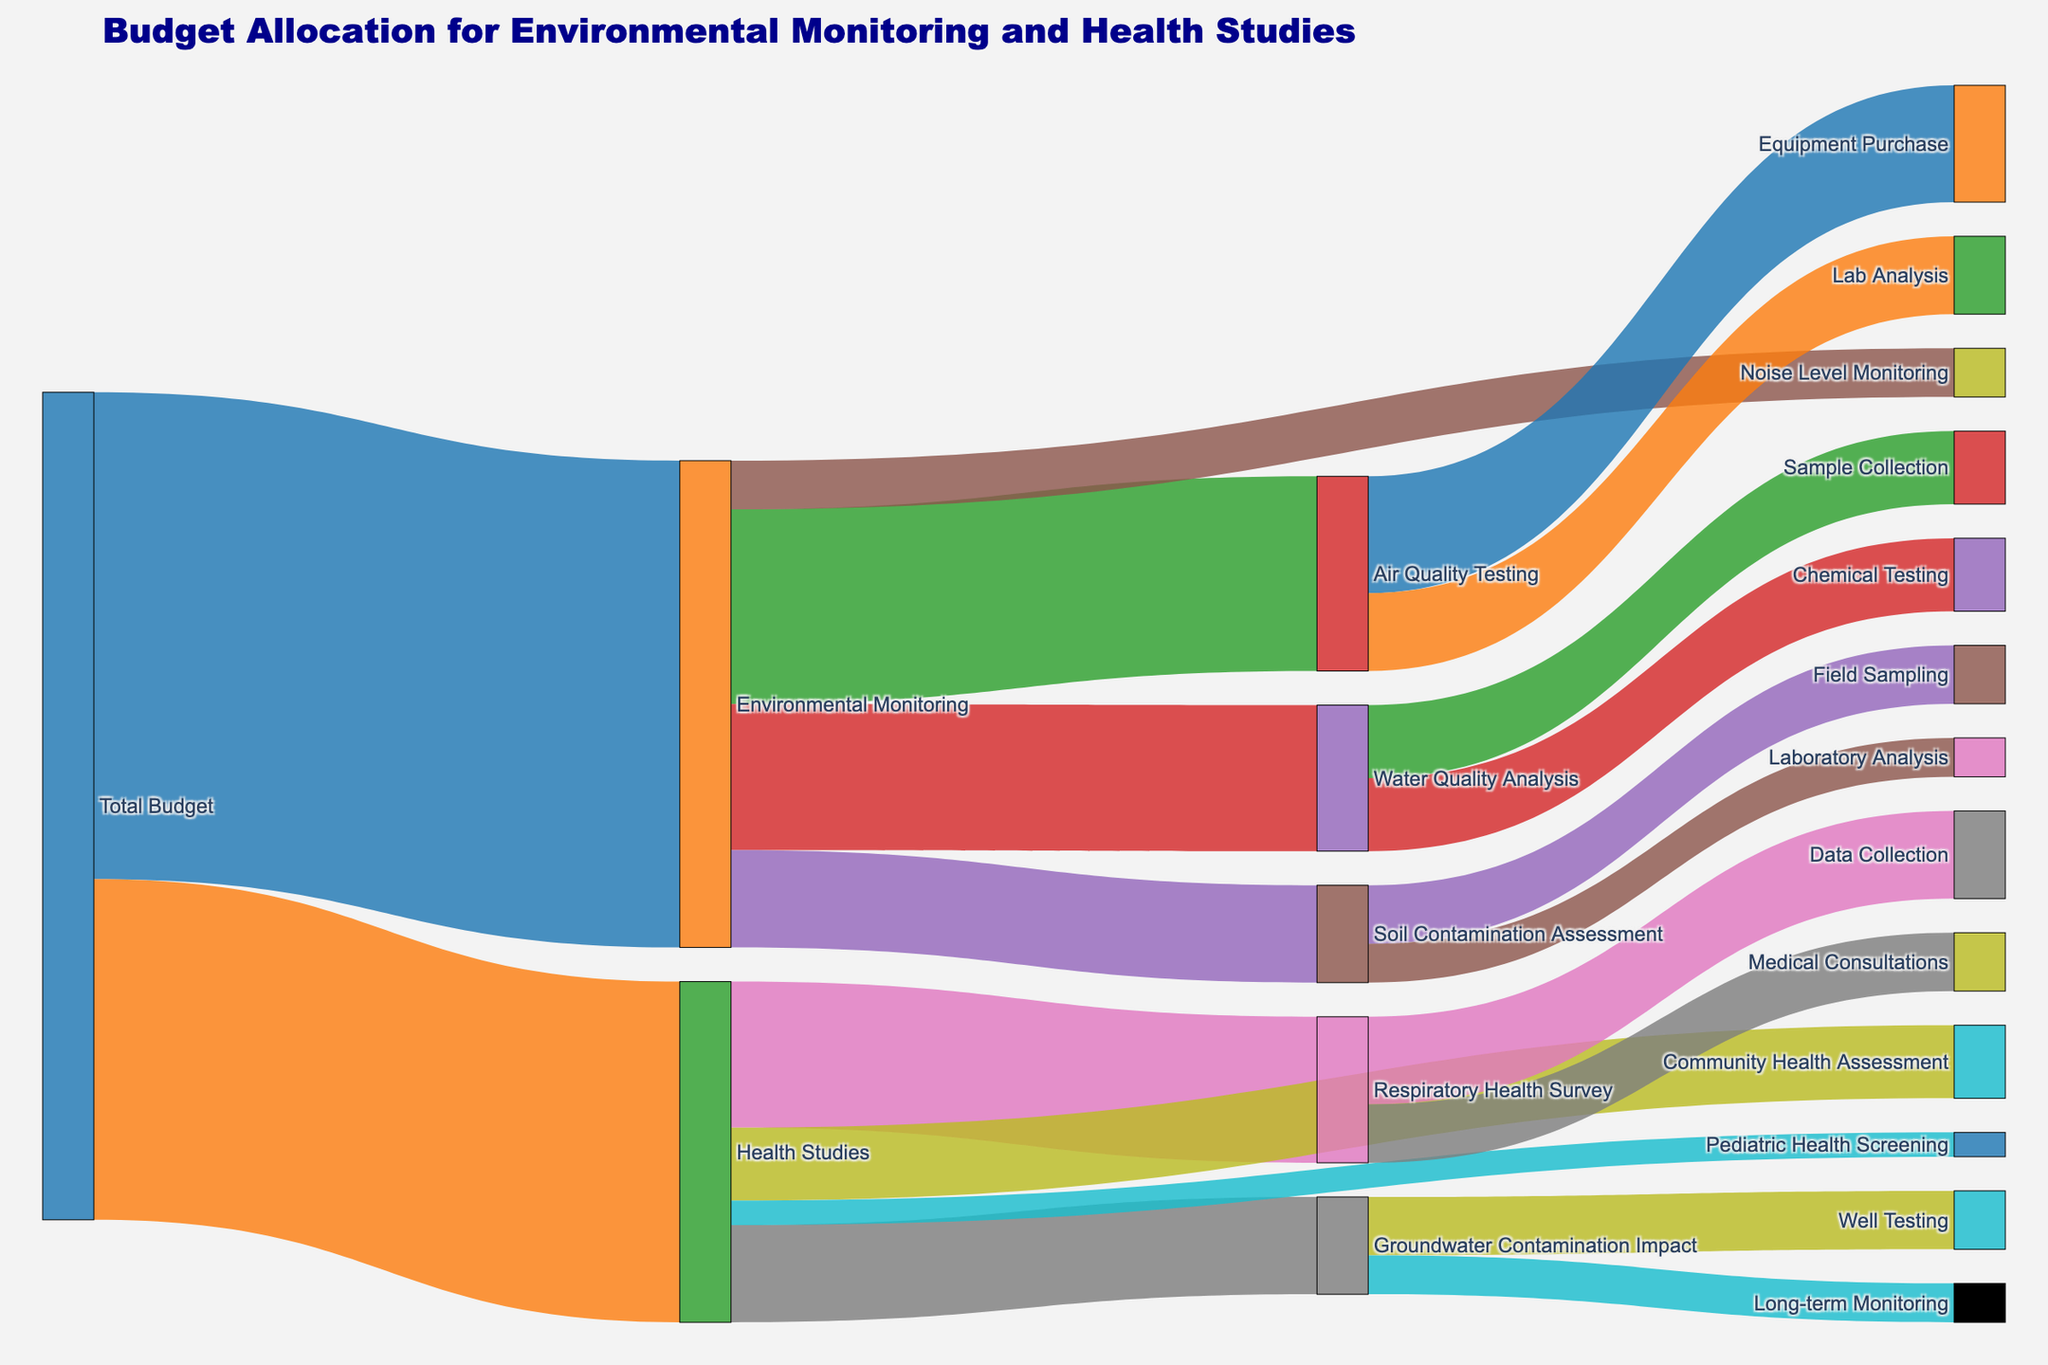What is the total budget for Environmental Monitoring? The figure shows four allocations under "Environmental Monitoring": Air Quality Testing, Water Quality Analysis, Soil Contamination Assessment, and Noise Level Monitoring. To find the total, sum these values: 200,000 + 150,000 + 100,000 + 50,000.
Answer: 500,000 What is the smallest allocation under Health Studies? The figure lists four allocations under "Health Studies": Respiratory Health Survey, Groundwater Contamination Impact, Community Health Assessment, and Pediatric Health Screening. The values are 150,000, 100,000, 75,000, and 25,000, respectively. The smallest among these is Pediatric Health Screening.
Answer: 25,000 How does the budget for Air Quality Testing compare to the budget for Water Quality Analysis? The figure shows that the budget for Air Quality Testing is 200,000 and for Water Quality Analysis is 150,000. Comparing these, Air Quality Testing receives a greater budget by 50,000.
Answer: Greater by 50,000 What is the total budget allocated specifically for Air Quality Testing, and what are its sub-categories? The total budget for Air Quality Testing is given as 200,000, which is split into Equipment Purchase (120,000) and Lab Analysis (80,000).
Answer: 200,000; Equipment Purchase and Lab Analysis Which specific activity under Environmental Monitoring receives the least funding? Under Environmental Monitoring, the activities are Air Quality Testing (200,000), Water Quality Analysis (150,000), Soil Contamination Assessment (100,000), and Noise Level Monitoring (50,000). The least funded activity is Noise Level Monitoring.
Answer: Noise Level Monitoring How much total budget is allocated to activities that deal directly with the community's health? Activities under Health Studies directly related to community health are Respiratory Health Survey (150,000), Groundwater Contamination Impact (100,000), Community Health Assessment (75,000), and Pediatric Health Screening (25,000). Adding these gives 350,000.
Answer: 350,000 Compare the budget allocation between Equipment Purchase for Air Quality Testing and Well Testing for Groundwater Contamination Impact? The budget for Equipment Purchase under Air Quality Testing is 120,000, while Well Testing under Groundwater Contamination Impact receives 60,000. Equipment Purchase has the larger allocation.
Answer: Equipment Purchase has 60,000 more What percentage of the total Health Studies budget is allocated to Respiratory Health Survey? The total budget for Health Studies is 350,000, with Respiratory Health Survey receiving 150,000. The percentage is calculated as (150,000 / 350,000) * 100%.
Answer: 42.86% How do the budgets for Laboratory Analysis under Soil Contamination Assessment and Long-term Monitoring under Groundwater Contamination Impact compare? Laboratory Analysis under Soil Contamination Assessment is allocated 40,000, while Long-term Monitoring under Groundwater Contamination Impact is also allocated 40,000. Both have equal budgets.
Answer: Equal What is the total budget allocated to testing (both Air and Water Quality)? The total budget for Air Quality Testing is 200,000, and for Water Quality Analysis is 150,000. Summing these gives 350,000.
Answer: 350,000 